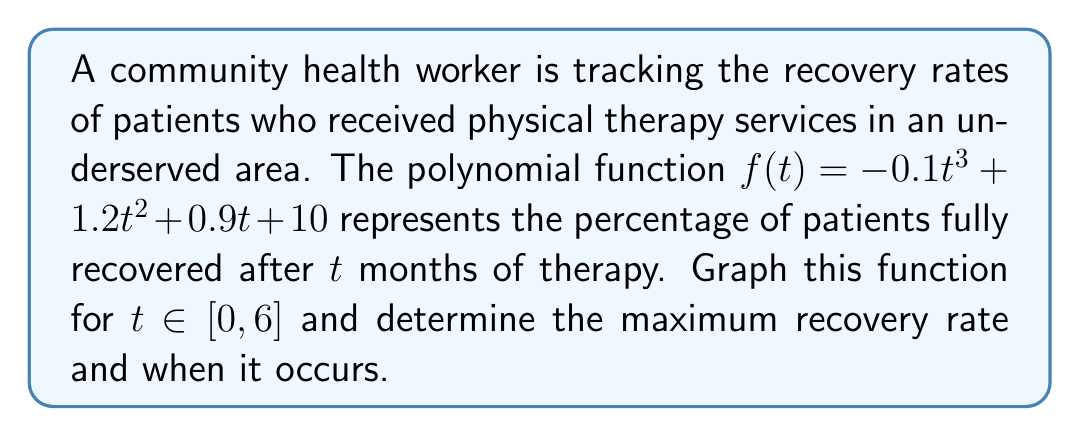Can you answer this question? To graph the polynomial function and find the maximum recovery rate, we'll follow these steps:

1) First, let's identify the key features of the polynomial:
   $f(t) = -0.1t^3 + 1.2t^2 + 0.9t + 10$
   This is a cubic function with a negative leading coefficient.

2) To find the critical points, we need to find the derivative and set it to zero:
   $f'(t) = -0.3t^2 + 2.4t + 0.9$
   $-0.3t^2 + 2.4t + 0.9 = 0$

3) Solve this quadratic equation:
   $t = \frac{-2.4 \pm \sqrt{2.4^2 - 4(-0.3)(0.9)}}{2(-0.3)}$
   $t \approx 0.35$ or $t \approx 5.65$

4) Since we're only considering $t \in [0, 6]$, both critical points are relevant.

5) Evaluate $f(t)$ at $t = 0, 0.35, 5.65,$ and $6$ to determine the y-intercept and the y-values at critical points:
   $f(0) = 10$
   $f(0.35) \approx 10.35$
   $f(5.65) \approx 28.16$
   $f(6) \approx 27.4$

6) Plot these points and sketch the curve:

[asy]
import graph;
size(200,200);
real f(real t) {return -0.1*t^3 + 1.2*t^2 + 0.9*t + 10;}
draw(graph(f,0,6),blue);
dot((0,10));
dot((0.35,10.35));
dot((5.65,28.16));
dot((6,27.4));
xaxis("t (months)",0,6.5,arrow=Arrow);
yaxis("Recovery rate (%)",0,30,arrow=Arrow);
label("(5.65, 28.16)",(5.65,28.16),NE);
[/asy]

7) From the graph and calculations, we can see that the maximum recovery rate occurs at $t \approx 5.65$ months, with a recovery rate of approximately 28.16%.
Answer: Maximum recovery rate: 28.16% at 5.65 months 